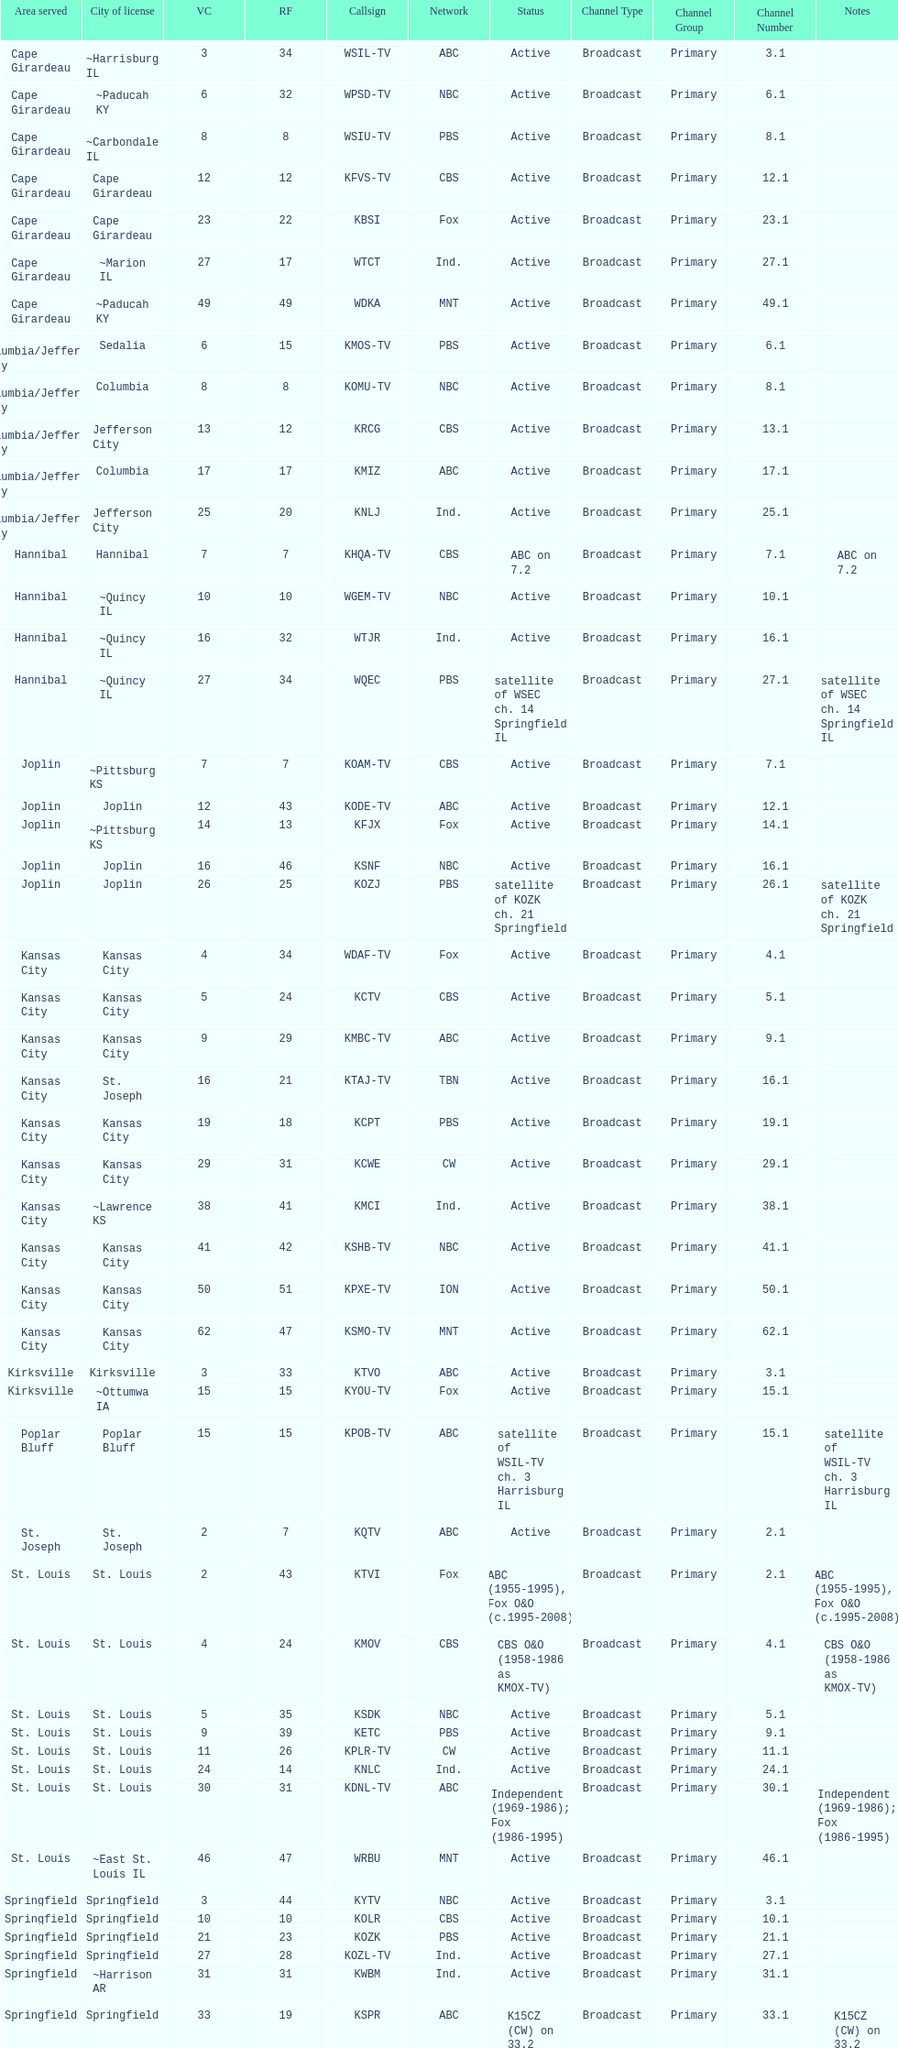Parse the full table. {'header': ['Area served', 'City of license', 'VC', 'RF', 'Callsign', 'Network', 'Status', 'Channel Type', 'Channel Group', 'Channel Number', 'Notes'], 'rows': [['Cape Girardeau', '~Harrisburg IL', '3', '34', 'WSIL-TV', 'ABC', 'Active', 'Broadcast', 'Primary', '3.1', ''], ['Cape Girardeau', '~Paducah KY', '6', '32', 'WPSD-TV', 'NBC', 'Active', 'Broadcast', 'Primary', '6.1', ''], ['Cape Girardeau', '~Carbondale IL', '8', '8', 'WSIU-TV', 'PBS', 'Active', 'Broadcast', 'Primary', '8.1', ''], ['Cape Girardeau', 'Cape Girardeau', '12', '12', 'KFVS-TV', 'CBS', 'Active', 'Broadcast', 'Primary', '12.1', ''], ['Cape Girardeau', 'Cape Girardeau', '23', '22', 'KBSI', 'Fox', 'Active', 'Broadcast', 'Primary', '23.1', ''], ['Cape Girardeau', '~Marion IL', '27', '17', 'WTCT', 'Ind.', 'Active', 'Broadcast', 'Primary', '27.1', ''], ['Cape Girardeau', '~Paducah KY', '49', '49', 'WDKA', 'MNT', 'Active', 'Broadcast', 'Primary', '49.1', ''], ['Columbia/Jefferson City', 'Sedalia', '6', '15', 'KMOS-TV', 'PBS', 'Active', 'Broadcast', 'Primary', '6.1', ''], ['Columbia/Jefferson City', 'Columbia', '8', '8', 'KOMU-TV', 'NBC', 'Active', 'Broadcast', 'Primary', '8.1', ''], ['Columbia/Jefferson City', 'Jefferson City', '13', '12', 'KRCG', 'CBS', 'Active', 'Broadcast', 'Primary', '13.1', ''], ['Columbia/Jefferson City', 'Columbia', '17', '17', 'KMIZ', 'ABC', 'Active', 'Broadcast', 'Primary', '17.1', ''], ['Columbia/Jefferson City', 'Jefferson City', '25', '20', 'KNLJ', 'Ind.', 'Active', 'Broadcast', 'Primary', '25.1', ''], ['Hannibal', 'Hannibal', '7', '7', 'KHQA-TV', 'CBS', 'ABC on 7.2', 'Broadcast', 'Primary', '7.1', 'ABC on 7.2'], ['Hannibal', '~Quincy IL', '10', '10', 'WGEM-TV', 'NBC', 'Active', 'Broadcast', 'Primary', '10.1', ''], ['Hannibal', '~Quincy IL', '16', '32', 'WTJR', 'Ind.', 'Active', 'Broadcast', 'Primary', '16.1', ''], ['Hannibal', '~Quincy IL', '27', '34', 'WQEC', 'PBS', 'satellite of WSEC ch. 14 Springfield IL', 'Broadcast', 'Primary', '27.1', 'satellite of WSEC ch. 14 Springfield IL'], ['Joplin', '~Pittsburg KS', '7', '7', 'KOAM-TV', 'CBS', 'Active', 'Broadcast', 'Primary', '7.1', ''], ['Joplin', 'Joplin', '12', '43', 'KODE-TV', 'ABC', 'Active', 'Broadcast', 'Primary', '12.1', ''], ['Joplin', '~Pittsburg KS', '14', '13', 'KFJX', 'Fox', 'Active', 'Broadcast', 'Primary', '14.1', ''], ['Joplin', 'Joplin', '16', '46', 'KSNF', 'NBC', 'Active', 'Broadcast', 'Primary', '16.1', ''], ['Joplin', 'Joplin', '26', '25', 'KOZJ', 'PBS', 'satellite of KOZK ch. 21 Springfield', 'Broadcast', 'Primary', '26.1', 'satellite of KOZK ch. 21 Springfield'], ['Kansas City', 'Kansas City', '4', '34', 'WDAF-TV', 'Fox', 'Active', 'Broadcast', 'Primary', '4.1', ''], ['Kansas City', 'Kansas City', '5', '24', 'KCTV', 'CBS', 'Active', 'Broadcast', 'Primary', '5.1', ''], ['Kansas City', 'Kansas City', '9', '29', 'KMBC-TV', 'ABC', 'Active', 'Broadcast', 'Primary', '9.1', ''], ['Kansas City', 'St. Joseph', '16', '21', 'KTAJ-TV', 'TBN', 'Active', 'Broadcast', 'Primary', '16.1', ''], ['Kansas City', 'Kansas City', '19', '18', 'KCPT', 'PBS', 'Active', 'Broadcast', 'Primary', '19.1', ''], ['Kansas City', 'Kansas City', '29', '31', 'KCWE', 'CW', 'Active', 'Broadcast', 'Primary', '29.1', ''], ['Kansas City', '~Lawrence KS', '38', '41', 'KMCI', 'Ind.', 'Active', 'Broadcast', 'Primary', '38.1', ''], ['Kansas City', 'Kansas City', '41', '42', 'KSHB-TV', 'NBC', 'Active', 'Broadcast', 'Primary', '41.1', ''], ['Kansas City', 'Kansas City', '50', '51', 'KPXE-TV', 'ION', 'Active', 'Broadcast', 'Primary', '50.1', ''], ['Kansas City', 'Kansas City', '62', '47', 'KSMO-TV', 'MNT', 'Active', 'Broadcast', 'Primary', '62.1', ''], ['Kirksville', 'Kirksville', '3', '33', 'KTVO', 'ABC', 'Active', 'Broadcast', 'Primary', '3.1', ''], ['Kirksville', '~Ottumwa IA', '15', '15', 'KYOU-TV', 'Fox', 'Active', 'Broadcast', 'Primary', '15.1', ''], ['Poplar Bluff', 'Poplar Bluff', '15', '15', 'KPOB-TV', 'ABC', 'satellite of WSIL-TV ch. 3 Harrisburg IL', 'Broadcast', 'Primary', '15.1', 'satellite of WSIL-TV ch. 3 Harrisburg IL'], ['St. Joseph', 'St. Joseph', '2', '7', 'KQTV', 'ABC', 'Active', 'Broadcast', 'Primary', '2.1', ''], ['St. Louis', 'St. Louis', '2', '43', 'KTVI', 'Fox', 'ABC (1955-1995), Fox O&O (c.1995-2008)', 'Broadcast', 'Primary', '2.1', 'ABC (1955-1995), Fox O&O (c.1995-2008)'], ['St. Louis', 'St. Louis', '4', '24', 'KMOV', 'CBS', 'CBS O&O (1958-1986 as KMOX-TV)', 'Broadcast', 'Primary', '4.1', 'CBS O&O (1958-1986 as KMOX-TV)'], ['St. Louis', 'St. Louis', '5', '35', 'KSDK', 'NBC', 'Active', 'Broadcast', 'Primary', '5.1', ''], ['St. Louis', 'St. Louis', '9', '39', 'KETC', 'PBS', 'Active', 'Broadcast', 'Primary', '9.1', ''], ['St. Louis', 'St. Louis', '11', '26', 'KPLR-TV', 'CW', 'Active', 'Broadcast', 'Primary', '11.1', ''], ['St. Louis', 'St. Louis', '24', '14', 'KNLC', 'Ind.', 'Active', 'Broadcast', 'Primary', '24.1', ''], ['St. Louis', 'St. Louis', '30', '31', 'KDNL-TV', 'ABC', 'Independent (1969-1986); Fox (1986-1995)', 'Broadcast', 'Primary', '30.1', 'Independent (1969-1986); Fox (1986-1995)'], ['St. Louis', '~East St. Louis IL', '46', '47', 'WRBU', 'MNT', 'Active', 'Broadcast', 'Primary', '46.1', ''], ['Springfield', 'Springfield', '3', '44', 'KYTV', 'NBC', 'Active', 'Broadcast', 'Primary', '3.1', ''], ['Springfield', 'Springfield', '10', '10', 'KOLR', 'CBS', 'Active', 'Broadcast', 'Primary', '10.1', ''], ['Springfield', 'Springfield', '21', '23', 'KOZK', 'PBS', 'Active', 'Broadcast', 'Primary', '21.1', ''], ['Springfield', 'Springfield', '27', '28', 'KOZL-TV', 'Ind.', 'Active', 'Broadcast', 'Primary', '27.1', ''], ['Springfield', '~Harrison AR', '31', '31', 'KWBM', 'Ind.', 'Active', 'Broadcast', 'Primary', '31.1', ''], ['Springfield', 'Springfield', '33', '19', 'KSPR', 'ABC', 'K15CZ (CW) on 33.2', 'Broadcast', 'Primary', '33.1', 'K15CZ (CW) on 33.2'], ['Springfield', 'Osage Beach', '49', '49', 'KRBK', 'Fox', 'Active', 'Broadcast', 'Primary', '49.1', ''], ['Springfield', 'Springfield', '8', '8', 'KRFT-LD', 'MundoFox', 'TNN on 8.2, My Family TV on 8.3', 'Broadcast', 'Primary', '8.1', 'TNN on 8.2, My Family TV on 8.3']]} How many areas have at least 5 stations? 6. 